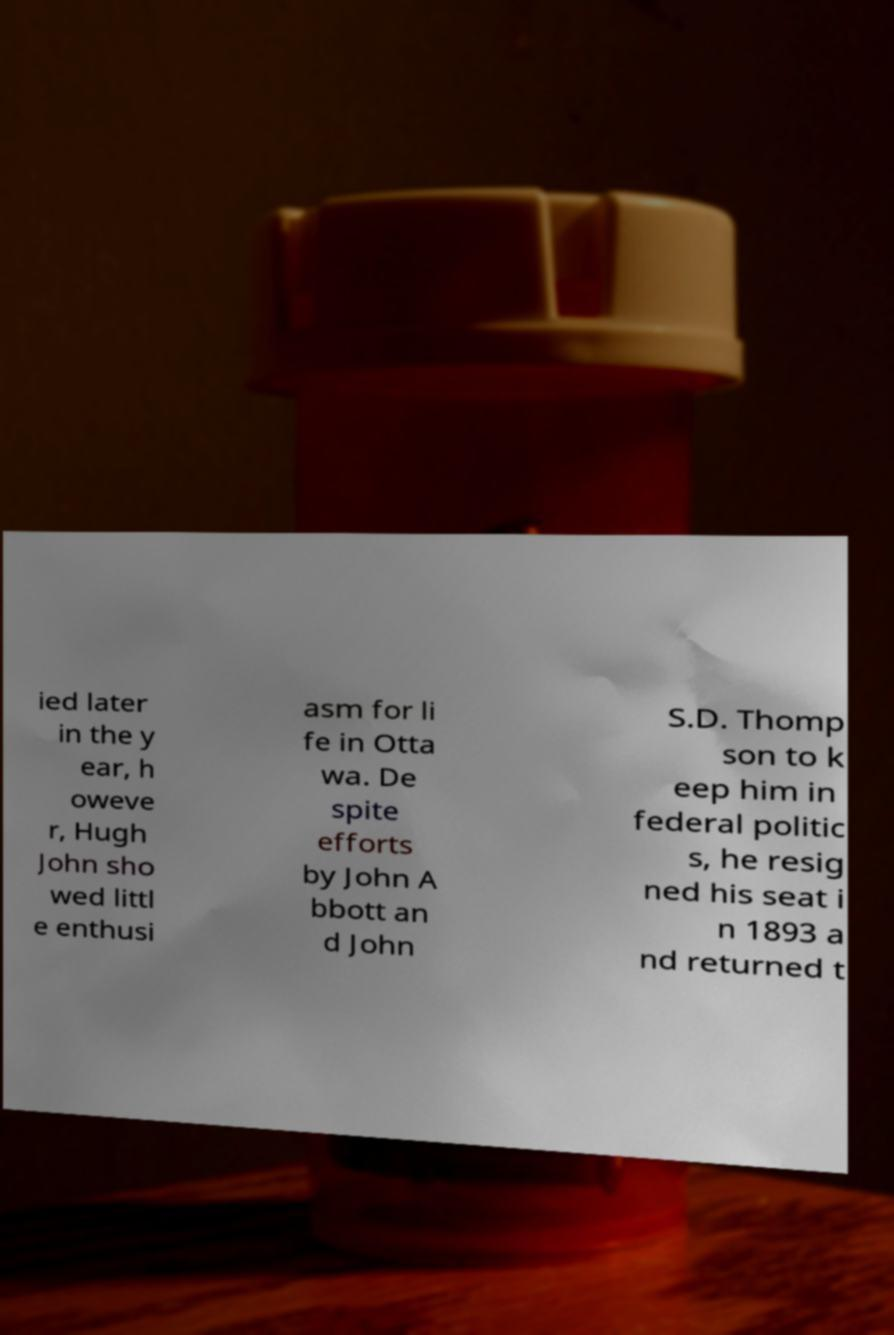Please identify and transcribe the text found in this image. ied later in the y ear, h oweve r, Hugh John sho wed littl e enthusi asm for li fe in Otta wa. De spite efforts by John A bbott an d John S.D. Thomp son to k eep him in federal politic s, he resig ned his seat i n 1893 a nd returned t 